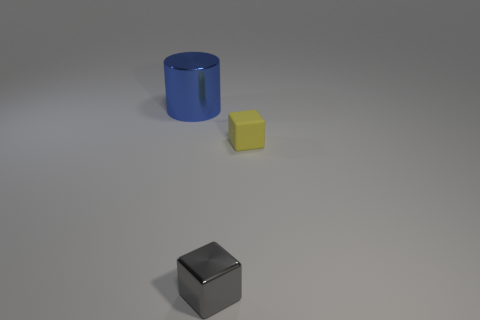Are there the same number of large blue metal cylinders behind the big thing and large gray cylinders?
Your answer should be very brief. Yes. Is the number of metal things in front of the rubber cube less than the number of small shiny spheres?
Offer a terse response. No. Is there a blue cube that has the same size as the blue cylinder?
Your answer should be very brief. No. What number of shiny blocks are in front of the block to the left of the yellow thing?
Keep it short and to the point. 0. What color is the thing that is on the left side of the tiny cube that is in front of the yellow rubber object?
Keep it short and to the point. Blue. There is a thing that is behind the small metallic cube and on the right side of the big blue cylinder; what is its material?
Offer a very short reply. Rubber. Are there any small gray shiny objects that have the same shape as the big metal thing?
Offer a terse response. No. Is the shape of the tiny object to the left of the matte cube the same as  the small rubber object?
Offer a very short reply. Yes. What number of things are to the left of the rubber object and in front of the blue metallic cylinder?
Your response must be concise. 1. What is the shape of the yellow rubber object that is to the right of the tiny gray thing?
Keep it short and to the point. Cube. 